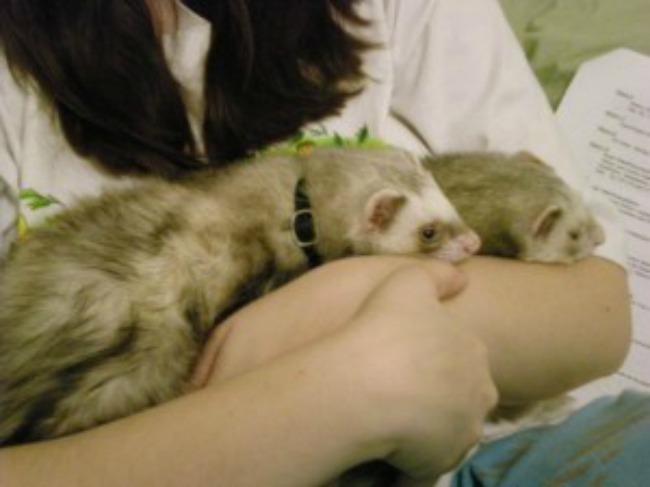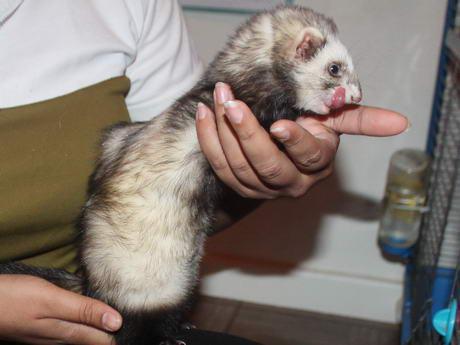The first image is the image on the left, the second image is the image on the right. Assess this claim about the two images: "One or more ferrets is being held by a human in each photo.". Correct or not? Answer yes or no. Yes. The first image is the image on the left, the second image is the image on the right. Examine the images to the left and right. Is the description "The left image contains a ferret resting its head on another ferrets neck." accurate? Answer yes or no. No. 